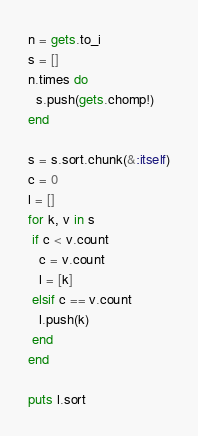<code> <loc_0><loc_0><loc_500><loc_500><_Ruby_>n = gets.to_i
s = []
n.times do
  s.push(gets.chomp!)
end

s = s.sort.chunk(&:itself)
c = 0
l = []
for k, v in s
 if c < v.count
   c = v.count
   l = [k]
 elsif c == v.count
   l.push(k)
 end
end

puts l.sort</code> 